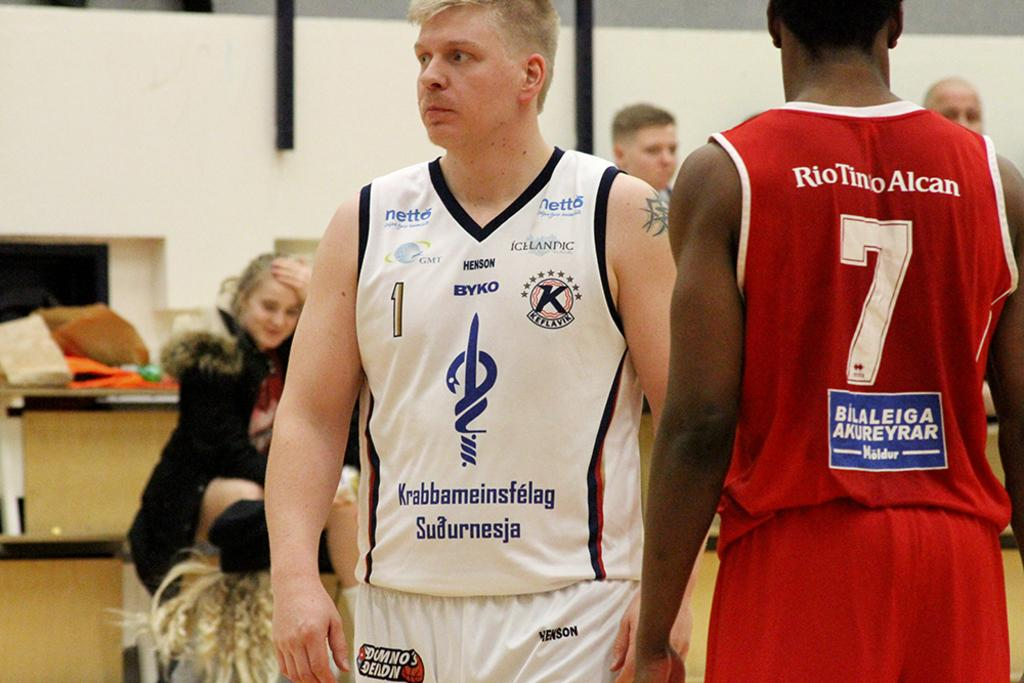<image>
Create a compact narrative representing the image presented. Basketball players are standing on the court and one of their jersey's says RioTino Alcan 7. 